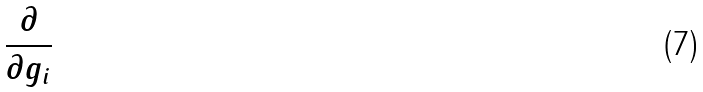<formula> <loc_0><loc_0><loc_500><loc_500>\frac { \partial } { \partial g _ { i } }</formula> 